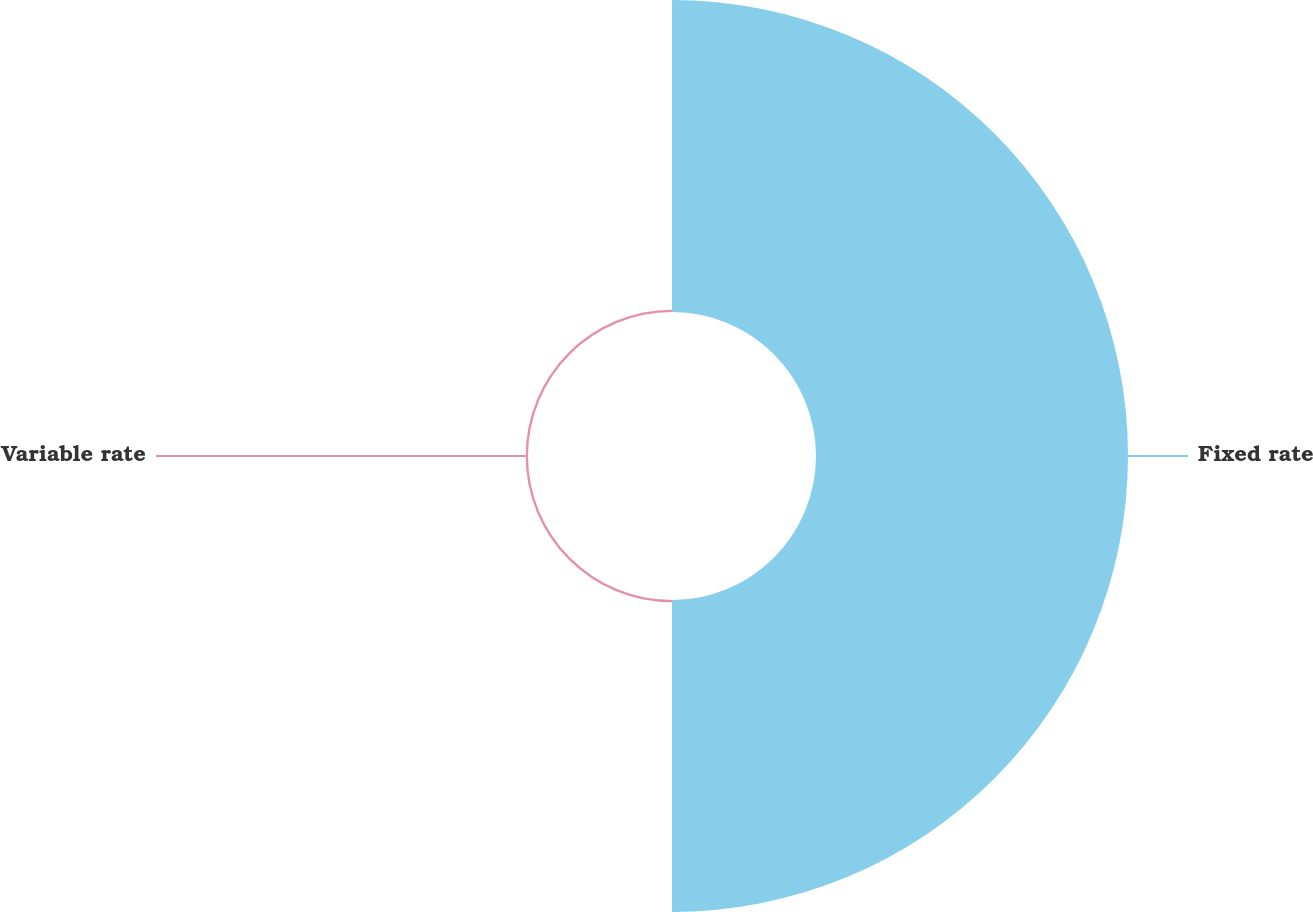Convert chart to OTSL. <chart><loc_0><loc_0><loc_500><loc_500><pie_chart><fcel>Fixed rate<fcel>Variable rate<nl><fcel>99.25%<fcel>0.75%<nl></chart> 